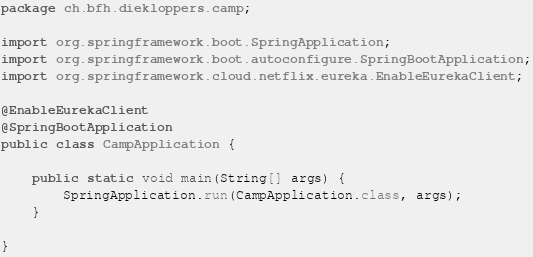Convert code to text. <code><loc_0><loc_0><loc_500><loc_500><_Java_>package ch.bfh.diekloppers.camp;

import org.springframework.boot.SpringApplication;
import org.springframework.boot.autoconfigure.SpringBootApplication;
import org.springframework.cloud.netflix.eureka.EnableEurekaClient;

@EnableEurekaClient
@SpringBootApplication
public class CampApplication {

	public static void main(String[] args) {
		SpringApplication.run(CampApplication.class, args);
	}

}
</code> 